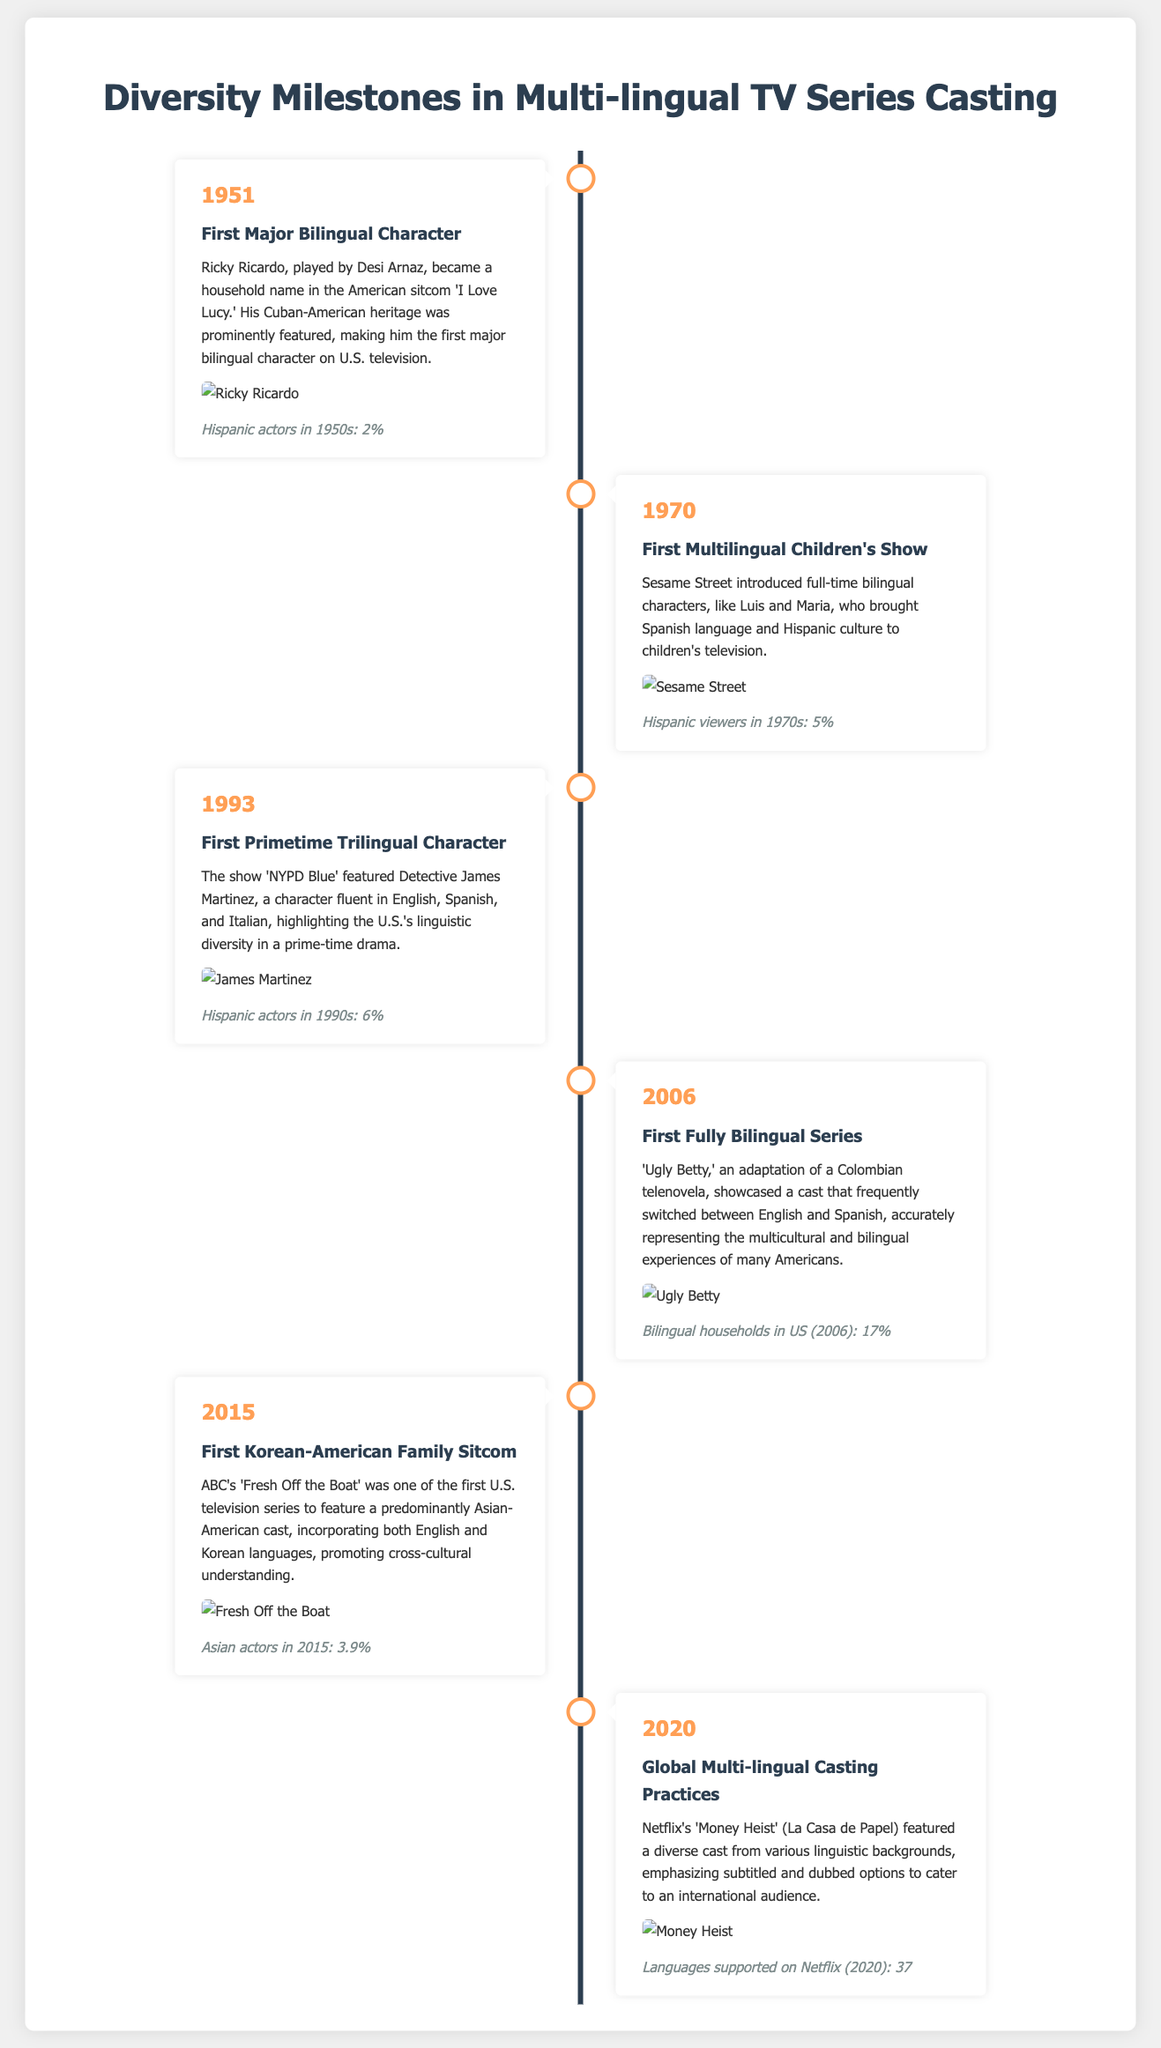What date was the first major bilingual character introduced? The document states that the first major bilingual character was introduced in 1951.
Answer: 1951 Who portrayed the first major bilingual character? The document mentions Desi Arnaz as the actor who played the first major bilingual character, Ricky Ricardo.
Answer: Desi Arnaz What percentage of Hispanic actors was there in the 1950s? The infographic notes that Hispanic actors represented 2% of the total actors in the 1950s.
Answer: 2% Which show featured the first trilingual character? According to the timeline, 'NYPD Blue' featured the first primetime trilingual character.
Answer: NYPD Blue What year did 'Ugly Betty' premiere? The document indicates that 'Ugly Betty,' the first fully bilingual series, premiered in 2006.
Answer: 2006 How many languages did Netflix support in 2020? The timeline specifies that Netflix supported 37 languages in 2020.
Answer: 37 What milestone involved the first Korean-American family sitcom? The document states that 'Fresh Off the Boat' was the first Korean-American family sitcom.
Answer: Fresh Off the Boat What does the timeline represent? The document illustrates significant diversity milestones in the casting of multi-lingual TV series.
Answer: Diversity milestones What type of characters were prominently featured in 'Sesame Street'? The infographic specifies that 'Sesame Street' introduced full-time bilingual characters.
Answer: Bilingual characters 